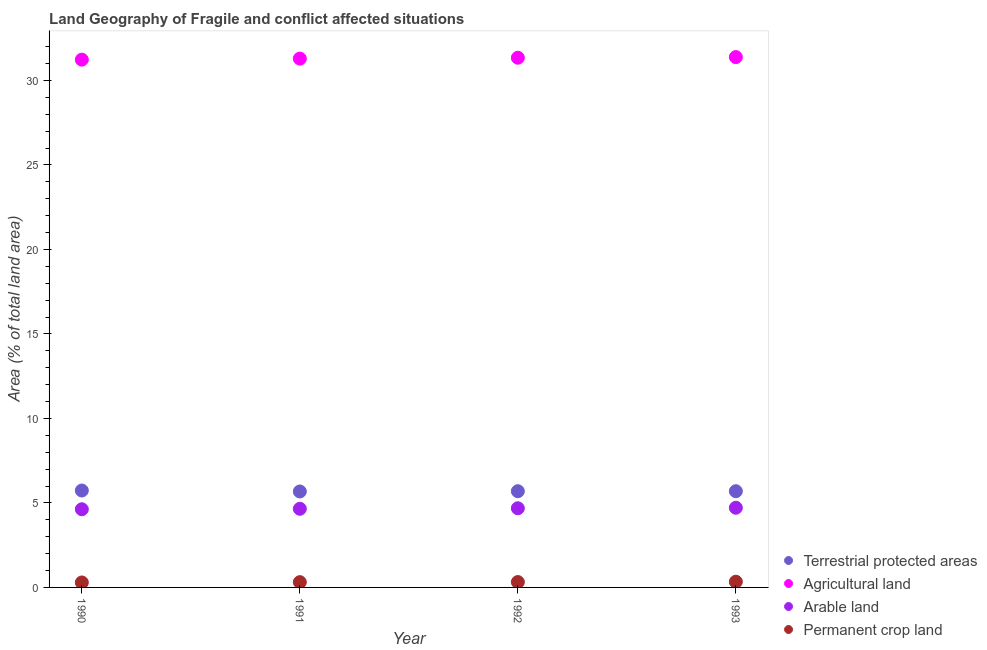Is the number of dotlines equal to the number of legend labels?
Your answer should be very brief. Yes. What is the percentage of land under terrestrial protection in 1992?
Your response must be concise. 5.69. Across all years, what is the maximum percentage of area under agricultural land?
Give a very brief answer. 31.38. Across all years, what is the minimum percentage of area under agricultural land?
Your answer should be compact. 31.23. In which year was the percentage of area under agricultural land maximum?
Ensure brevity in your answer.  1993. In which year was the percentage of area under permanent crop land minimum?
Your response must be concise. 1990. What is the total percentage of area under permanent crop land in the graph?
Give a very brief answer. 1.26. What is the difference between the percentage of area under agricultural land in 1990 and that in 1993?
Keep it short and to the point. -0.15. What is the difference between the percentage of area under agricultural land in 1991 and the percentage of area under permanent crop land in 1992?
Offer a very short reply. 30.97. What is the average percentage of area under arable land per year?
Make the answer very short. 4.67. In the year 1990, what is the difference between the percentage of area under agricultural land and percentage of area under arable land?
Your answer should be very brief. 26.6. What is the ratio of the percentage of land under terrestrial protection in 1991 to that in 1993?
Offer a terse response. 1. Is the percentage of area under permanent crop land in 1990 less than that in 1992?
Your answer should be very brief. Yes. Is the difference between the percentage of land under terrestrial protection in 1992 and 1993 greater than the difference between the percentage of area under permanent crop land in 1992 and 1993?
Make the answer very short. Yes. What is the difference between the highest and the second highest percentage of area under agricultural land?
Your answer should be very brief. 0.04. What is the difference between the highest and the lowest percentage of area under arable land?
Offer a terse response. 0.09. Is the sum of the percentage of area under agricultural land in 1991 and 1992 greater than the maximum percentage of area under arable land across all years?
Give a very brief answer. Yes. Is it the case that in every year, the sum of the percentage of land under terrestrial protection and percentage of area under agricultural land is greater than the percentage of area under arable land?
Provide a short and direct response. Yes. Is the percentage of land under terrestrial protection strictly greater than the percentage of area under agricultural land over the years?
Your answer should be very brief. No. How many years are there in the graph?
Make the answer very short. 4. Does the graph contain grids?
Provide a short and direct response. No. Where does the legend appear in the graph?
Offer a very short reply. Bottom right. What is the title of the graph?
Keep it short and to the point. Land Geography of Fragile and conflict affected situations. What is the label or title of the Y-axis?
Keep it short and to the point. Area (% of total land area). What is the Area (% of total land area) in Terrestrial protected areas in 1990?
Provide a succinct answer. 5.73. What is the Area (% of total land area) of Agricultural land in 1990?
Provide a short and direct response. 31.23. What is the Area (% of total land area) of Arable land in 1990?
Offer a very short reply. 4.63. What is the Area (% of total land area) in Permanent crop land in 1990?
Your response must be concise. 0.29. What is the Area (% of total land area) of Terrestrial protected areas in 1991?
Offer a terse response. 5.68. What is the Area (% of total land area) in Agricultural land in 1991?
Offer a terse response. 31.29. What is the Area (% of total land area) in Arable land in 1991?
Your answer should be very brief. 4.65. What is the Area (% of total land area) in Permanent crop land in 1991?
Your answer should be compact. 0.31. What is the Area (% of total land area) of Terrestrial protected areas in 1992?
Offer a terse response. 5.69. What is the Area (% of total land area) of Agricultural land in 1992?
Your answer should be very brief. 31.34. What is the Area (% of total land area) in Arable land in 1992?
Offer a terse response. 4.68. What is the Area (% of total land area) of Permanent crop land in 1992?
Ensure brevity in your answer.  0.32. What is the Area (% of total land area) in Terrestrial protected areas in 1993?
Make the answer very short. 5.69. What is the Area (% of total land area) of Agricultural land in 1993?
Your answer should be compact. 31.38. What is the Area (% of total land area) in Arable land in 1993?
Your answer should be very brief. 4.71. What is the Area (% of total land area) in Permanent crop land in 1993?
Ensure brevity in your answer.  0.34. Across all years, what is the maximum Area (% of total land area) of Terrestrial protected areas?
Make the answer very short. 5.73. Across all years, what is the maximum Area (% of total land area) in Agricultural land?
Offer a very short reply. 31.38. Across all years, what is the maximum Area (% of total land area) in Arable land?
Your answer should be compact. 4.71. Across all years, what is the maximum Area (% of total land area) of Permanent crop land?
Your answer should be very brief. 0.34. Across all years, what is the minimum Area (% of total land area) in Terrestrial protected areas?
Keep it short and to the point. 5.68. Across all years, what is the minimum Area (% of total land area) of Agricultural land?
Provide a short and direct response. 31.23. Across all years, what is the minimum Area (% of total land area) in Arable land?
Ensure brevity in your answer.  4.63. Across all years, what is the minimum Area (% of total land area) of Permanent crop land?
Your answer should be compact. 0.29. What is the total Area (% of total land area) in Terrestrial protected areas in the graph?
Keep it short and to the point. 22.8. What is the total Area (% of total land area) of Agricultural land in the graph?
Keep it short and to the point. 125.24. What is the total Area (% of total land area) in Arable land in the graph?
Keep it short and to the point. 18.68. What is the total Area (% of total land area) in Permanent crop land in the graph?
Ensure brevity in your answer.  1.26. What is the difference between the Area (% of total land area) in Terrestrial protected areas in 1990 and that in 1991?
Ensure brevity in your answer.  0.06. What is the difference between the Area (% of total land area) in Agricultural land in 1990 and that in 1991?
Your answer should be very brief. -0.06. What is the difference between the Area (% of total land area) in Arable land in 1990 and that in 1991?
Offer a terse response. -0.03. What is the difference between the Area (% of total land area) of Permanent crop land in 1990 and that in 1991?
Your response must be concise. -0.02. What is the difference between the Area (% of total land area) in Terrestrial protected areas in 1990 and that in 1992?
Your answer should be compact. 0.04. What is the difference between the Area (% of total land area) of Agricultural land in 1990 and that in 1992?
Provide a short and direct response. -0.11. What is the difference between the Area (% of total land area) in Arable land in 1990 and that in 1992?
Your answer should be compact. -0.06. What is the difference between the Area (% of total land area) in Permanent crop land in 1990 and that in 1992?
Offer a very short reply. -0.02. What is the difference between the Area (% of total land area) in Terrestrial protected areas in 1990 and that in 1993?
Offer a very short reply. 0.04. What is the difference between the Area (% of total land area) in Agricultural land in 1990 and that in 1993?
Provide a short and direct response. -0.15. What is the difference between the Area (% of total land area) in Arable land in 1990 and that in 1993?
Your answer should be very brief. -0.09. What is the difference between the Area (% of total land area) in Permanent crop land in 1990 and that in 1993?
Your answer should be very brief. -0.04. What is the difference between the Area (% of total land area) of Terrestrial protected areas in 1991 and that in 1992?
Give a very brief answer. -0.01. What is the difference between the Area (% of total land area) of Agricultural land in 1991 and that in 1992?
Keep it short and to the point. -0.05. What is the difference between the Area (% of total land area) in Arable land in 1991 and that in 1992?
Your answer should be compact. -0.03. What is the difference between the Area (% of total land area) of Permanent crop land in 1991 and that in 1992?
Offer a very short reply. -0.01. What is the difference between the Area (% of total land area) in Terrestrial protected areas in 1991 and that in 1993?
Offer a terse response. -0.02. What is the difference between the Area (% of total land area) in Agricultural land in 1991 and that in 1993?
Ensure brevity in your answer.  -0.09. What is the difference between the Area (% of total land area) in Arable land in 1991 and that in 1993?
Ensure brevity in your answer.  -0.06. What is the difference between the Area (% of total land area) of Permanent crop land in 1991 and that in 1993?
Offer a very short reply. -0.03. What is the difference between the Area (% of total land area) of Terrestrial protected areas in 1992 and that in 1993?
Provide a short and direct response. -0. What is the difference between the Area (% of total land area) of Agricultural land in 1992 and that in 1993?
Offer a very short reply. -0.04. What is the difference between the Area (% of total land area) in Arable land in 1992 and that in 1993?
Your response must be concise. -0.03. What is the difference between the Area (% of total land area) of Permanent crop land in 1992 and that in 1993?
Give a very brief answer. -0.02. What is the difference between the Area (% of total land area) in Terrestrial protected areas in 1990 and the Area (% of total land area) in Agricultural land in 1991?
Offer a terse response. -25.56. What is the difference between the Area (% of total land area) of Terrestrial protected areas in 1990 and the Area (% of total land area) of Arable land in 1991?
Offer a very short reply. 1.08. What is the difference between the Area (% of total land area) in Terrestrial protected areas in 1990 and the Area (% of total land area) in Permanent crop land in 1991?
Offer a very short reply. 5.42. What is the difference between the Area (% of total land area) of Agricultural land in 1990 and the Area (% of total land area) of Arable land in 1991?
Your answer should be very brief. 26.58. What is the difference between the Area (% of total land area) in Agricultural land in 1990 and the Area (% of total land area) in Permanent crop land in 1991?
Give a very brief answer. 30.92. What is the difference between the Area (% of total land area) of Arable land in 1990 and the Area (% of total land area) of Permanent crop land in 1991?
Provide a short and direct response. 4.31. What is the difference between the Area (% of total land area) of Terrestrial protected areas in 1990 and the Area (% of total land area) of Agricultural land in 1992?
Offer a very short reply. -25.61. What is the difference between the Area (% of total land area) in Terrestrial protected areas in 1990 and the Area (% of total land area) in Permanent crop land in 1992?
Your answer should be compact. 5.42. What is the difference between the Area (% of total land area) in Agricultural land in 1990 and the Area (% of total land area) in Arable land in 1992?
Your answer should be very brief. 26.54. What is the difference between the Area (% of total land area) of Agricultural land in 1990 and the Area (% of total land area) of Permanent crop land in 1992?
Make the answer very short. 30.91. What is the difference between the Area (% of total land area) in Arable land in 1990 and the Area (% of total land area) in Permanent crop land in 1992?
Your answer should be very brief. 4.31. What is the difference between the Area (% of total land area) in Terrestrial protected areas in 1990 and the Area (% of total land area) in Agricultural land in 1993?
Keep it short and to the point. -25.65. What is the difference between the Area (% of total land area) of Terrestrial protected areas in 1990 and the Area (% of total land area) of Arable land in 1993?
Your answer should be very brief. 1.02. What is the difference between the Area (% of total land area) of Terrestrial protected areas in 1990 and the Area (% of total land area) of Permanent crop land in 1993?
Your response must be concise. 5.4. What is the difference between the Area (% of total land area) in Agricultural land in 1990 and the Area (% of total land area) in Arable land in 1993?
Keep it short and to the point. 26.51. What is the difference between the Area (% of total land area) of Agricultural land in 1990 and the Area (% of total land area) of Permanent crop land in 1993?
Your answer should be compact. 30.89. What is the difference between the Area (% of total land area) in Arable land in 1990 and the Area (% of total land area) in Permanent crop land in 1993?
Your answer should be very brief. 4.29. What is the difference between the Area (% of total land area) in Terrestrial protected areas in 1991 and the Area (% of total land area) in Agricultural land in 1992?
Offer a very short reply. -25.66. What is the difference between the Area (% of total land area) of Terrestrial protected areas in 1991 and the Area (% of total land area) of Permanent crop land in 1992?
Your answer should be very brief. 5.36. What is the difference between the Area (% of total land area) of Agricultural land in 1991 and the Area (% of total land area) of Arable land in 1992?
Provide a succinct answer. 26.61. What is the difference between the Area (% of total land area) in Agricultural land in 1991 and the Area (% of total land area) in Permanent crop land in 1992?
Your response must be concise. 30.97. What is the difference between the Area (% of total land area) of Arable land in 1991 and the Area (% of total land area) of Permanent crop land in 1992?
Keep it short and to the point. 4.34. What is the difference between the Area (% of total land area) of Terrestrial protected areas in 1991 and the Area (% of total land area) of Agricultural land in 1993?
Keep it short and to the point. -25.7. What is the difference between the Area (% of total land area) of Terrestrial protected areas in 1991 and the Area (% of total land area) of Arable land in 1993?
Offer a very short reply. 0.96. What is the difference between the Area (% of total land area) of Terrestrial protected areas in 1991 and the Area (% of total land area) of Permanent crop land in 1993?
Your answer should be very brief. 5.34. What is the difference between the Area (% of total land area) in Agricultural land in 1991 and the Area (% of total land area) in Arable land in 1993?
Ensure brevity in your answer.  26.58. What is the difference between the Area (% of total land area) in Agricultural land in 1991 and the Area (% of total land area) in Permanent crop land in 1993?
Your response must be concise. 30.95. What is the difference between the Area (% of total land area) in Arable land in 1991 and the Area (% of total land area) in Permanent crop land in 1993?
Provide a succinct answer. 4.32. What is the difference between the Area (% of total land area) of Terrestrial protected areas in 1992 and the Area (% of total land area) of Agricultural land in 1993?
Provide a succinct answer. -25.69. What is the difference between the Area (% of total land area) of Terrestrial protected areas in 1992 and the Area (% of total land area) of Arable land in 1993?
Your answer should be compact. 0.98. What is the difference between the Area (% of total land area) in Terrestrial protected areas in 1992 and the Area (% of total land area) in Permanent crop land in 1993?
Keep it short and to the point. 5.35. What is the difference between the Area (% of total land area) in Agricultural land in 1992 and the Area (% of total land area) in Arable land in 1993?
Offer a terse response. 26.63. What is the difference between the Area (% of total land area) in Agricultural land in 1992 and the Area (% of total land area) in Permanent crop land in 1993?
Provide a succinct answer. 31. What is the difference between the Area (% of total land area) in Arable land in 1992 and the Area (% of total land area) in Permanent crop land in 1993?
Offer a very short reply. 4.35. What is the average Area (% of total land area) of Terrestrial protected areas per year?
Provide a short and direct response. 5.7. What is the average Area (% of total land area) of Agricultural land per year?
Make the answer very short. 31.31. What is the average Area (% of total land area) of Arable land per year?
Offer a terse response. 4.67. What is the average Area (% of total land area) in Permanent crop land per year?
Offer a very short reply. 0.32. In the year 1990, what is the difference between the Area (% of total land area) in Terrestrial protected areas and Area (% of total land area) in Agricultural land?
Offer a terse response. -25.49. In the year 1990, what is the difference between the Area (% of total land area) of Terrestrial protected areas and Area (% of total land area) of Arable land?
Give a very brief answer. 1.11. In the year 1990, what is the difference between the Area (% of total land area) in Terrestrial protected areas and Area (% of total land area) in Permanent crop land?
Provide a succinct answer. 5.44. In the year 1990, what is the difference between the Area (% of total land area) in Agricultural land and Area (% of total land area) in Arable land?
Provide a short and direct response. 26.6. In the year 1990, what is the difference between the Area (% of total land area) of Agricultural land and Area (% of total land area) of Permanent crop land?
Your response must be concise. 30.94. In the year 1990, what is the difference between the Area (% of total land area) of Arable land and Area (% of total land area) of Permanent crop land?
Keep it short and to the point. 4.33. In the year 1991, what is the difference between the Area (% of total land area) of Terrestrial protected areas and Area (% of total land area) of Agricultural land?
Offer a terse response. -25.61. In the year 1991, what is the difference between the Area (% of total land area) in Terrestrial protected areas and Area (% of total land area) in Arable land?
Give a very brief answer. 1.02. In the year 1991, what is the difference between the Area (% of total land area) in Terrestrial protected areas and Area (% of total land area) in Permanent crop land?
Offer a very short reply. 5.37. In the year 1991, what is the difference between the Area (% of total land area) in Agricultural land and Area (% of total land area) in Arable land?
Provide a short and direct response. 26.64. In the year 1991, what is the difference between the Area (% of total land area) in Agricultural land and Area (% of total land area) in Permanent crop land?
Keep it short and to the point. 30.98. In the year 1991, what is the difference between the Area (% of total land area) of Arable land and Area (% of total land area) of Permanent crop land?
Your answer should be compact. 4.34. In the year 1992, what is the difference between the Area (% of total land area) of Terrestrial protected areas and Area (% of total land area) of Agricultural land?
Your response must be concise. -25.65. In the year 1992, what is the difference between the Area (% of total land area) of Terrestrial protected areas and Area (% of total land area) of Arable land?
Your answer should be compact. 1.01. In the year 1992, what is the difference between the Area (% of total land area) in Terrestrial protected areas and Area (% of total land area) in Permanent crop land?
Provide a short and direct response. 5.38. In the year 1992, what is the difference between the Area (% of total land area) in Agricultural land and Area (% of total land area) in Arable land?
Make the answer very short. 26.66. In the year 1992, what is the difference between the Area (% of total land area) in Agricultural land and Area (% of total land area) in Permanent crop land?
Your answer should be compact. 31.02. In the year 1992, what is the difference between the Area (% of total land area) in Arable land and Area (% of total land area) in Permanent crop land?
Ensure brevity in your answer.  4.37. In the year 1993, what is the difference between the Area (% of total land area) of Terrestrial protected areas and Area (% of total land area) of Agricultural land?
Provide a short and direct response. -25.69. In the year 1993, what is the difference between the Area (% of total land area) of Terrestrial protected areas and Area (% of total land area) of Arable land?
Your answer should be very brief. 0.98. In the year 1993, what is the difference between the Area (% of total land area) in Terrestrial protected areas and Area (% of total land area) in Permanent crop land?
Your answer should be compact. 5.36. In the year 1993, what is the difference between the Area (% of total land area) of Agricultural land and Area (% of total land area) of Arable land?
Offer a very short reply. 26.67. In the year 1993, what is the difference between the Area (% of total land area) in Agricultural land and Area (% of total land area) in Permanent crop land?
Offer a terse response. 31.04. In the year 1993, what is the difference between the Area (% of total land area) in Arable land and Area (% of total land area) in Permanent crop land?
Your answer should be very brief. 4.38. What is the ratio of the Area (% of total land area) in Terrestrial protected areas in 1990 to that in 1991?
Provide a short and direct response. 1.01. What is the ratio of the Area (% of total land area) of Permanent crop land in 1990 to that in 1991?
Your answer should be very brief. 0.94. What is the ratio of the Area (% of total land area) of Terrestrial protected areas in 1990 to that in 1992?
Ensure brevity in your answer.  1.01. What is the ratio of the Area (% of total land area) in Arable land in 1990 to that in 1992?
Provide a succinct answer. 0.99. What is the ratio of the Area (% of total land area) of Permanent crop land in 1990 to that in 1992?
Your response must be concise. 0.92. What is the ratio of the Area (% of total land area) in Arable land in 1990 to that in 1993?
Make the answer very short. 0.98. What is the ratio of the Area (% of total land area) in Permanent crop land in 1990 to that in 1993?
Your answer should be very brief. 0.87. What is the ratio of the Area (% of total land area) in Terrestrial protected areas in 1991 to that in 1992?
Your answer should be compact. 1. What is the ratio of the Area (% of total land area) in Arable land in 1991 to that in 1992?
Keep it short and to the point. 0.99. What is the ratio of the Area (% of total land area) of Permanent crop land in 1991 to that in 1992?
Offer a terse response. 0.98. What is the ratio of the Area (% of total land area) of Terrestrial protected areas in 1991 to that in 1993?
Your answer should be compact. 1. What is the ratio of the Area (% of total land area) of Arable land in 1991 to that in 1993?
Ensure brevity in your answer.  0.99. What is the ratio of the Area (% of total land area) of Permanent crop land in 1991 to that in 1993?
Your answer should be very brief. 0.93. What is the ratio of the Area (% of total land area) in Terrestrial protected areas in 1992 to that in 1993?
Provide a succinct answer. 1. What is the ratio of the Area (% of total land area) of Arable land in 1992 to that in 1993?
Make the answer very short. 0.99. What is the ratio of the Area (% of total land area) in Permanent crop land in 1992 to that in 1993?
Make the answer very short. 0.94. What is the difference between the highest and the second highest Area (% of total land area) in Terrestrial protected areas?
Keep it short and to the point. 0.04. What is the difference between the highest and the second highest Area (% of total land area) in Agricultural land?
Make the answer very short. 0.04. What is the difference between the highest and the second highest Area (% of total land area) in Arable land?
Offer a terse response. 0.03. What is the difference between the highest and the second highest Area (% of total land area) of Permanent crop land?
Give a very brief answer. 0.02. What is the difference between the highest and the lowest Area (% of total land area) of Terrestrial protected areas?
Keep it short and to the point. 0.06. What is the difference between the highest and the lowest Area (% of total land area) in Agricultural land?
Provide a succinct answer. 0.15. What is the difference between the highest and the lowest Area (% of total land area) of Arable land?
Your answer should be very brief. 0.09. What is the difference between the highest and the lowest Area (% of total land area) in Permanent crop land?
Offer a very short reply. 0.04. 